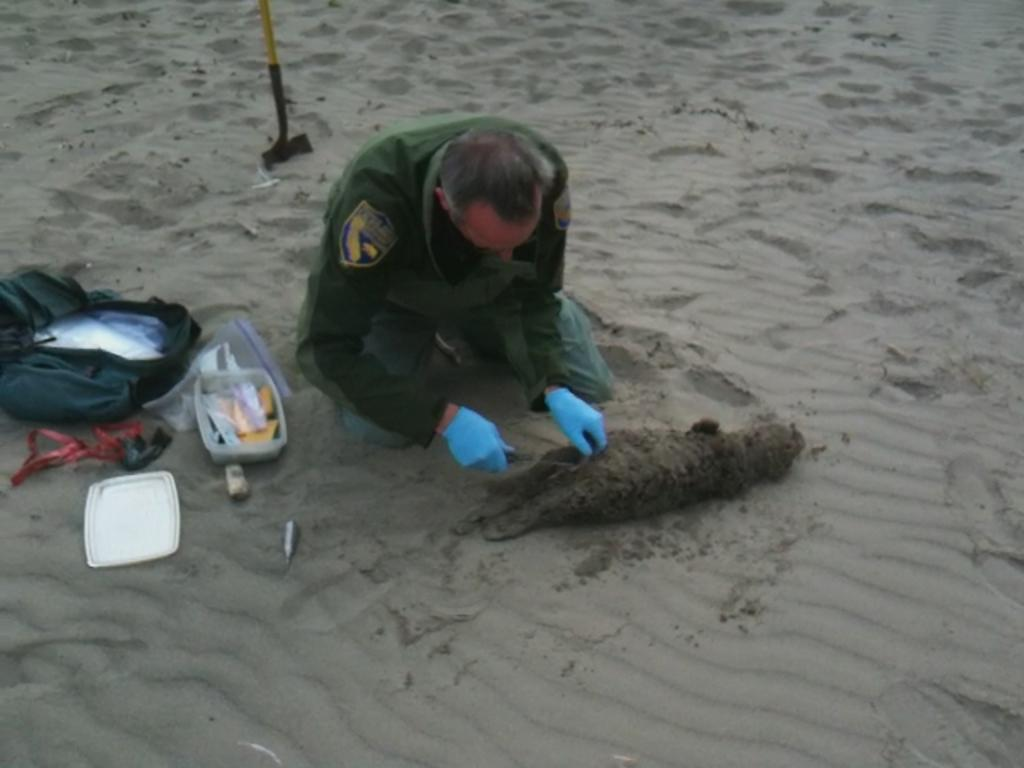Who is present in the image? There is a person in the image. What is the person holding in the image? The person is holding an object. What type of surface is the person standing on? The ground is covered with sand. What else can be seen in the image besides the person? There is a bag and a box visible in the image. What type of wall can be seen in the image? There is no wall present in the image. 